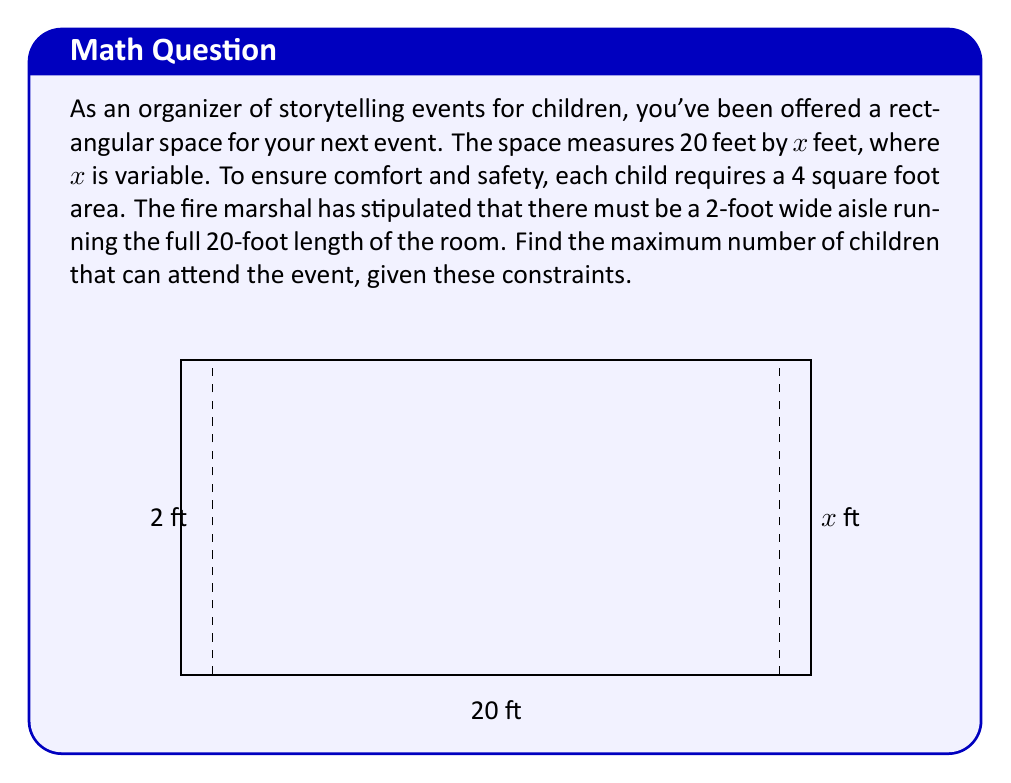Show me your answer to this math problem. Let's approach this problem step-by-step:

1) First, we need to express the area available for children in terms of x:
   Total area = 20x sq ft
   Aisle area = 2 * 20 = 40 sq ft
   Area for children = 20x - 40 sq ft

2) Each child needs 4 sq ft, so the number of children (N) is:
   $N = \frac{20x - 40}{4} = 5x - 10$

3) To find the maximum, we need to find the derivative of N with respect to x and set it to zero:
   $\frac{dN}{dx} = 5$

4) The derivative is always positive, which means N is always increasing as x increases. Therefore, the maximum will occur at the largest possible value of x.

5) The fire marshal's regulations typically limit the occupancy based on the exit capacity. Let's assume the maximum occupancy is 100 children.

6) We can find the required x by solving:
   $5x - 10 = 100$
   $5x = 110$
   $x = 22$ feet

7) Therefore, the maximum number of children occurs when x = 22 feet:
   $N_{max} = 5(22) - 10 = 100$
Answer: 100 children 